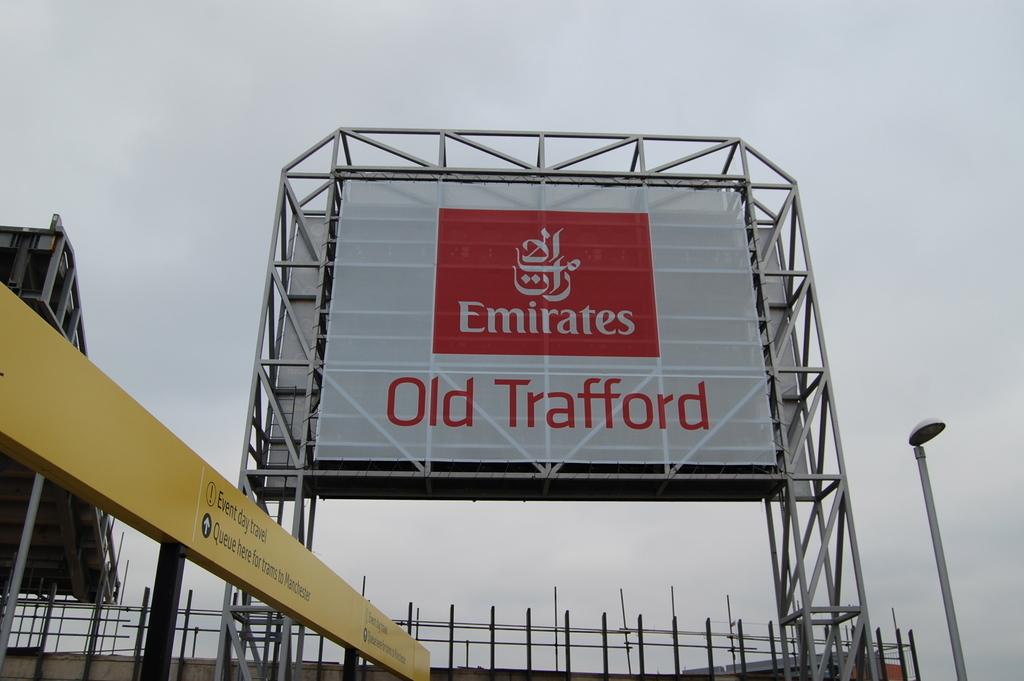Provide a one-sentence caption for the provided image. The billboard has the words Emirates written on it. 